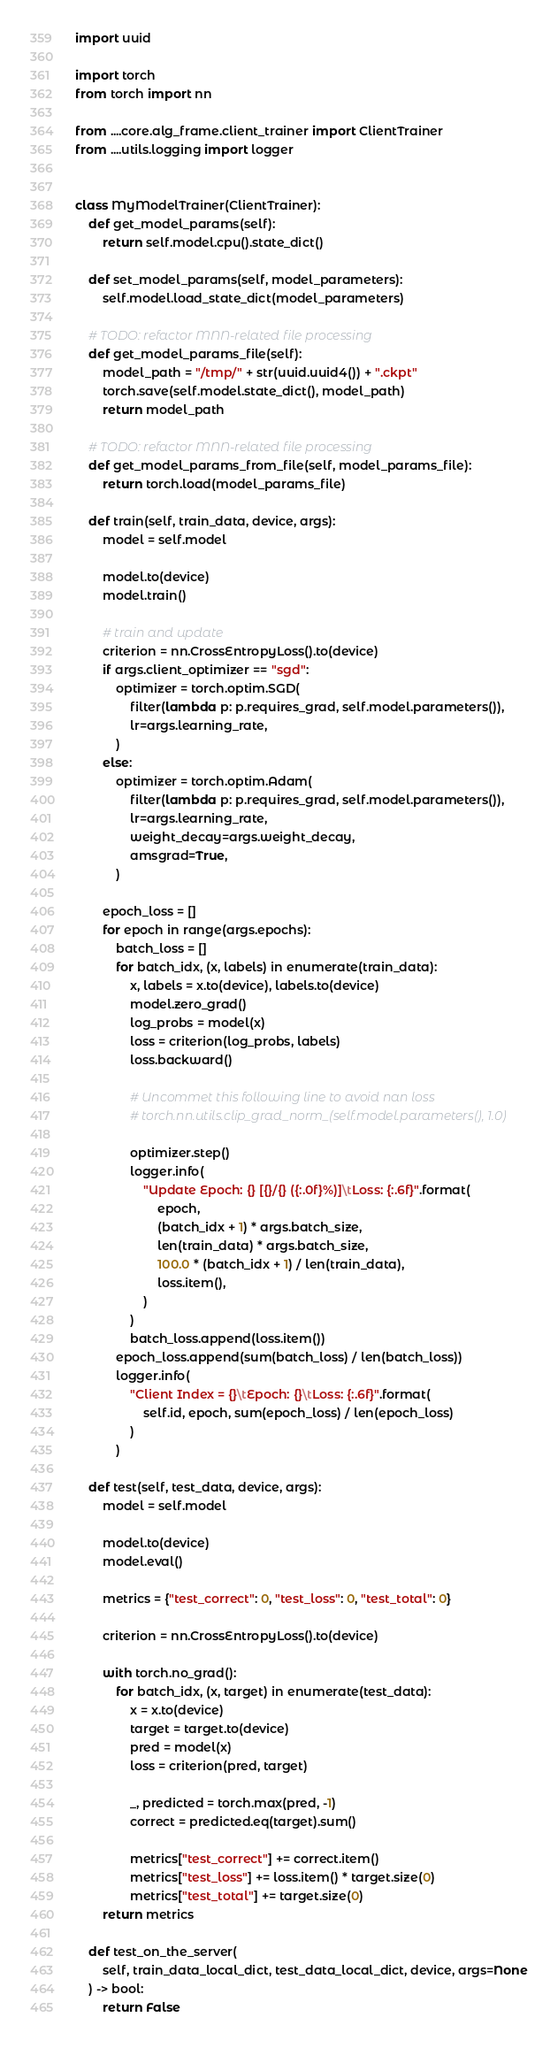Convert code to text. <code><loc_0><loc_0><loc_500><loc_500><_Python_>import uuid

import torch
from torch import nn

from ....core.alg_frame.client_trainer import ClientTrainer
from ....utils.logging import logger


class MyModelTrainer(ClientTrainer):
    def get_model_params(self):
        return self.model.cpu().state_dict()

    def set_model_params(self, model_parameters):
        self.model.load_state_dict(model_parameters)

    # TODO: refactor MNN-related file processing
    def get_model_params_file(self):
        model_path = "/tmp/" + str(uuid.uuid4()) + ".ckpt"
        torch.save(self.model.state_dict(), model_path)
        return model_path

    # TODO: refactor MNN-related file processing
    def get_model_params_from_file(self, model_params_file):
        return torch.load(model_params_file)

    def train(self, train_data, device, args):
        model = self.model

        model.to(device)
        model.train()

        # train and update
        criterion = nn.CrossEntropyLoss().to(device)
        if args.client_optimizer == "sgd":
            optimizer = torch.optim.SGD(
                filter(lambda p: p.requires_grad, self.model.parameters()),
                lr=args.learning_rate,
            )
        else:
            optimizer = torch.optim.Adam(
                filter(lambda p: p.requires_grad, self.model.parameters()),
                lr=args.learning_rate,
                weight_decay=args.weight_decay,
                amsgrad=True,
            )

        epoch_loss = []
        for epoch in range(args.epochs):
            batch_loss = []
            for batch_idx, (x, labels) in enumerate(train_data):
                x, labels = x.to(device), labels.to(device)
                model.zero_grad()
                log_probs = model(x)
                loss = criterion(log_probs, labels)
                loss.backward()

                # Uncommet this following line to avoid nan loss
                # torch.nn.utils.clip_grad_norm_(self.model.parameters(), 1.0)

                optimizer.step()
                logger.info(
                    "Update Epoch: {} [{}/{} ({:.0f}%)]\tLoss: {:.6f}".format(
                        epoch,
                        (batch_idx + 1) * args.batch_size,
                        len(train_data) * args.batch_size,
                        100.0 * (batch_idx + 1) / len(train_data),
                        loss.item(),
                    )
                )
                batch_loss.append(loss.item())
            epoch_loss.append(sum(batch_loss) / len(batch_loss))
            logger.info(
                "Client Index = {}\tEpoch: {}\tLoss: {:.6f}".format(
                    self.id, epoch, sum(epoch_loss) / len(epoch_loss)
                )
            )

    def test(self, test_data, device, args):
        model = self.model

        model.to(device)
        model.eval()

        metrics = {"test_correct": 0, "test_loss": 0, "test_total": 0}

        criterion = nn.CrossEntropyLoss().to(device)

        with torch.no_grad():
            for batch_idx, (x, target) in enumerate(test_data):
                x = x.to(device)
                target = target.to(device)
                pred = model(x)
                loss = criterion(pred, target)

                _, predicted = torch.max(pred, -1)
                correct = predicted.eq(target).sum()

                metrics["test_correct"] += correct.item()
                metrics["test_loss"] += loss.item() * target.size(0)
                metrics["test_total"] += target.size(0)
        return metrics

    def test_on_the_server(
        self, train_data_local_dict, test_data_local_dict, device, args=None
    ) -> bool:
        return False
</code> 